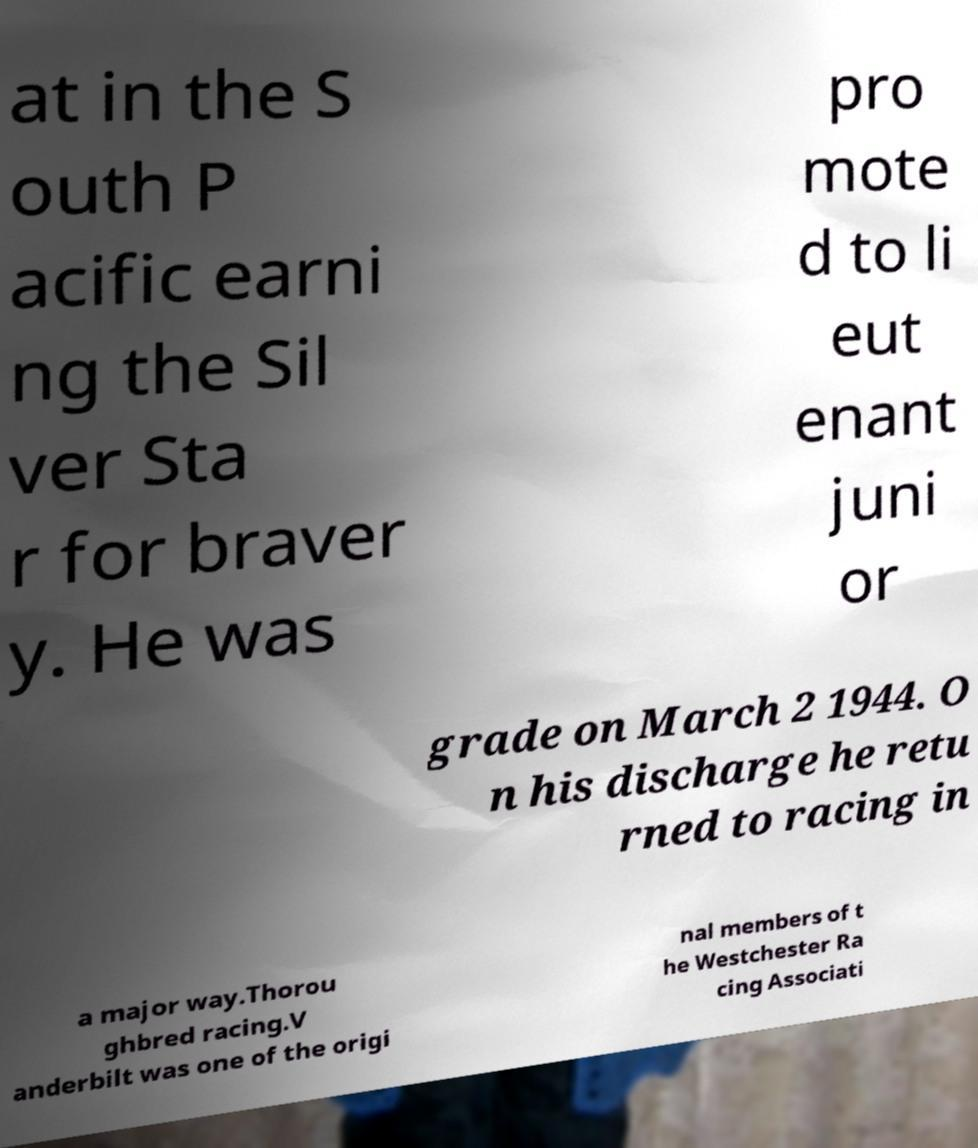For documentation purposes, I need the text within this image transcribed. Could you provide that? at in the S outh P acific earni ng the Sil ver Sta r for braver y. He was pro mote d to li eut enant juni or grade on March 2 1944. O n his discharge he retu rned to racing in a major way.Thorou ghbred racing.V anderbilt was one of the origi nal members of t he Westchester Ra cing Associati 